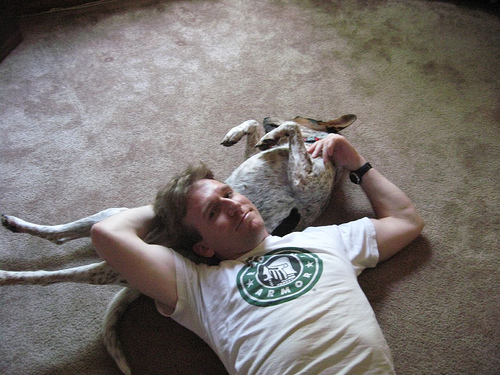<image>
Is there a dog under the man? Yes. The dog is positioned underneath the man, with the man above it in the vertical space. 